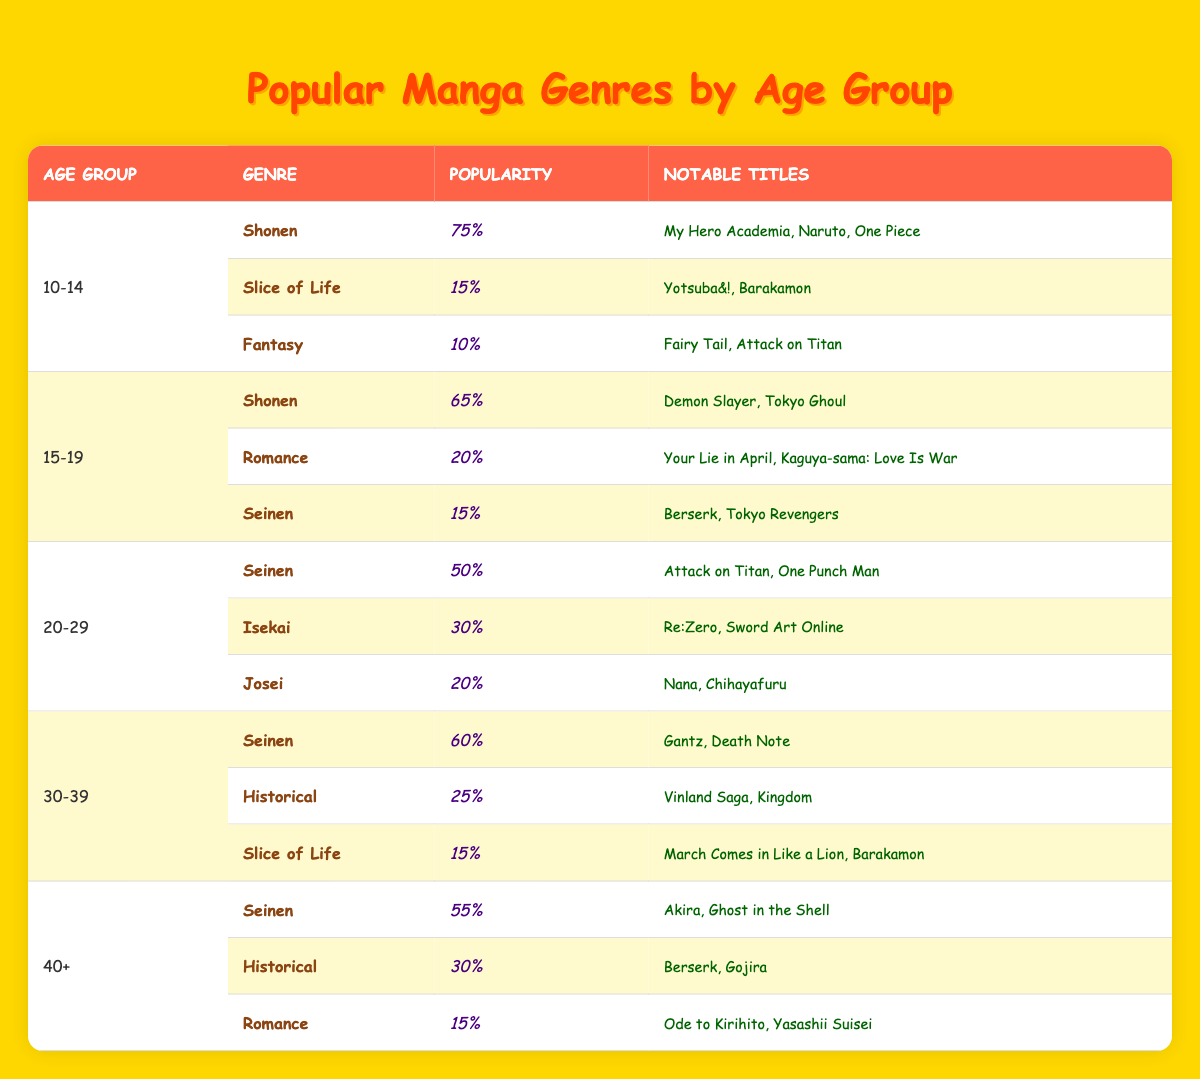What is the most popular genre among the 10-14 age group, and what is its popularity percentage? The most popular genre for the 10-14 age group is Shonen, which has a popularity percentage of 75%. This can be found in the first data entry for the 10-14 age range.
Answer: Shonen, 75% Which age group has the highest percentage of Seinen genre popularity? The 30-39 age group has the highest percentage of Seinen popularity, standing at 60%. This is compared against other age groups listed for Seinen, showing them to have lower percentages.
Answer: 30-39, 60% What is the combined popularity percentage of Historical and Romance genres for the 40+ age group? The Historical genre has a popularity of 30%, while the Romance genre has a popularity of 15%. Adding these together gives 30% + 15% = 45%.
Answer: 45% Is Fantasy a popular genre among readers aged 15-19? No, Fantasy is not a popular genre among readers aged 15-19, as it has a popularity percentage of only 15%, which is lower than the other listed genres in that age group.
Answer: No What is the average popularity percentage of Slice of Life across all age groups? The Slice of Life genres have popularity percentages of 15% for the 10-14 age group, 15% for the 30-39 age group, and the total is 30%. Dividing by the number of instances (2) gives an average of 30% / 2 = 15%.
Answer: 15% 